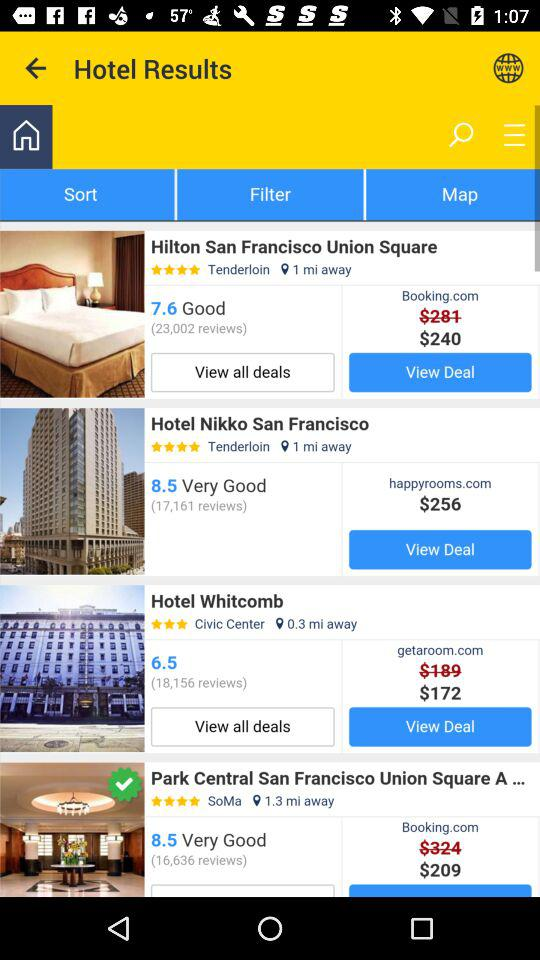How many reviews are there for "Hotel Nikko San Francisco"? There are 17,161 reviews. 